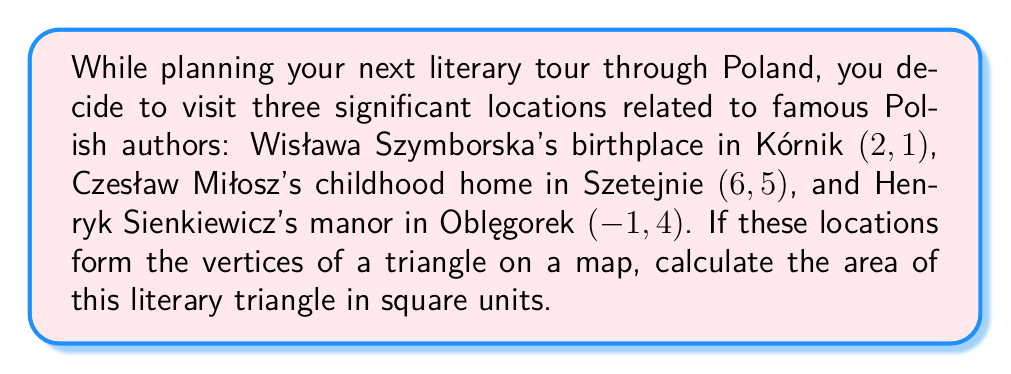Can you answer this question? To calculate the area of a triangle formed by three given points, we can use the formula:

$$\text{Area} = \frac{1}{2}|x_1(y_2 - y_3) + x_2(y_3 - y_1) + x_3(y_1 - y_2)|$$

Where $(x_1, y_1)$, $(x_2, y_2)$, and $(x_3, y_3)$ are the coordinates of the three points.

Let's assign our points:
$(x_1, y_1) = (2, 1)$ (Kórnik)
$(x_2, y_2) = (6, 5)$ (Szetejnie)
$(x_3, y_3) = (-1, 4)$ (Oblęgorek)

Now, let's substitute these values into the formula:

$$\begin{align*}
\text{Area} &= \frac{1}{2}|2(5 - 4) + 6(4 - 1) + (-1)(1 - 5)|\\
&= \frac{1}{2}|2(1) + 6(3) + (-1)(-4)|\\
&= \frac{1}{2}|2 + 18 + 4|\\
&= \frac{1}{2}|24|\\
&= \frac{1}{2}(24)\\
&= 12
\end{align*}$$

Therefore, the area of the triangle is 12 square units.

[asy]
unitsize(20);
dot((2,1));
dot((6,5));
dot((-1,4));
draw((2,1)--(6,5)--(-1,4)--cycle);
label("Kórnik (2,1)", (2,1), SE);
label("Szetejnie (6,5)", (6,5), NE);
label("Oblęgorek (-1,4)", (-1,4), NW);
[/asy]
Answer: The area of the literary triangle is 12 square units. 